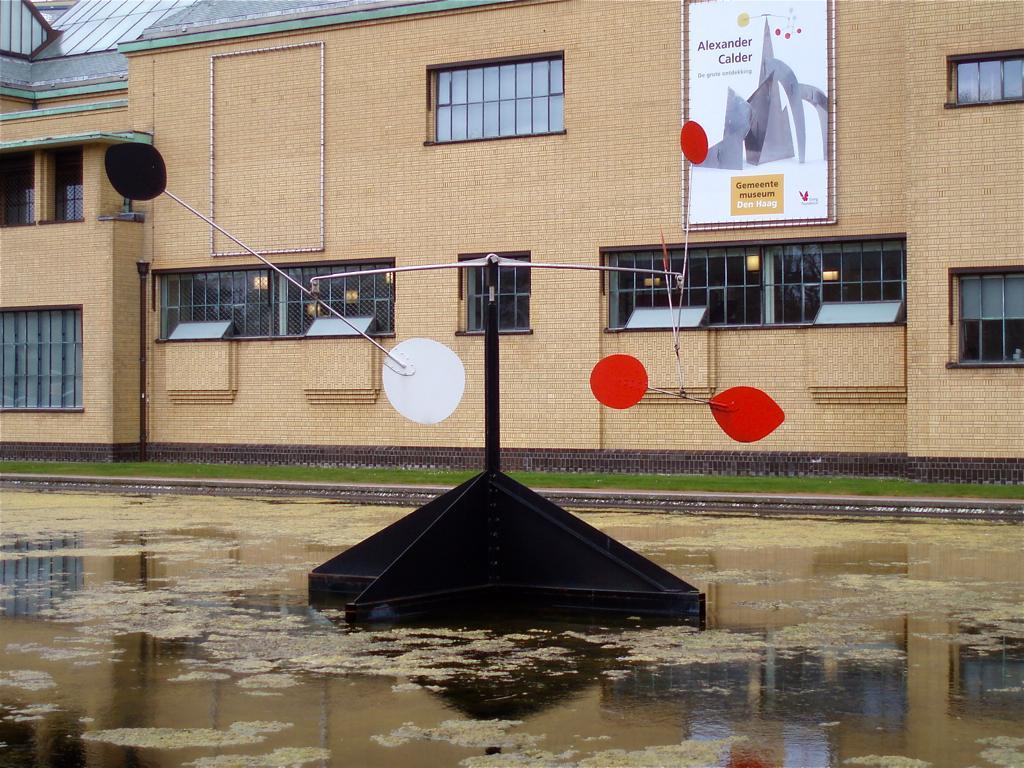Describe this image in one or two sentences. In the center of the image we can see a stand with some poles and boards placed in the water. In the background, we can see grass, building with windows, banner with some text and the roof 